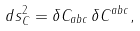<formula> <loc_0><loc_0><loc_500><loc_500>d s _ { C } ^ { 2 } = \delta C _ { a b c } \, \delta C ^ { a b c } ,</formula> 